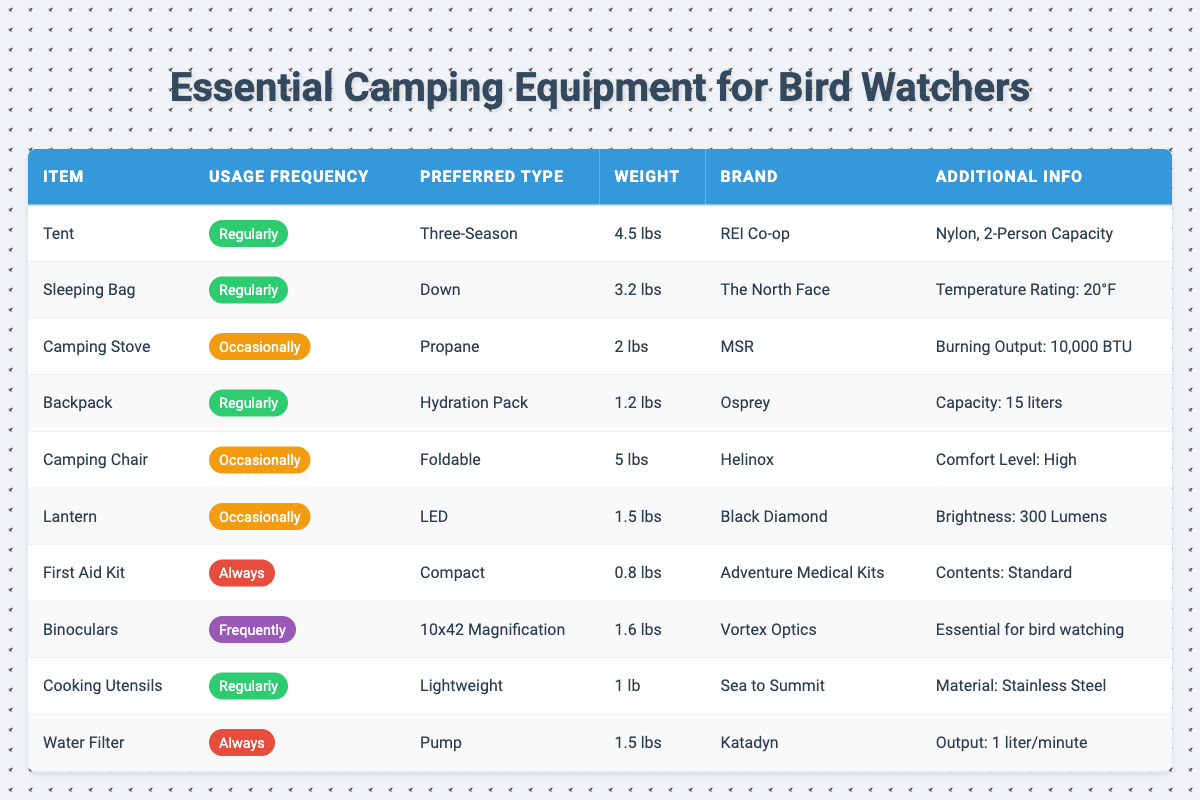What camping equipment is used regularly by travelers? We look for items listed with "Regularly" under the Usage Frequency column in the table. These items are: Tent, Sleeping Bag, Backpack, Cooking Utensils.
Answer: Tent, Sleeping Bag, Backpack, Cooking Utensils Which equipment has the highest weight? Check the Weight column for each item and identify the item with the largest value. Comparing weights, the Camping Chair is the heaviest at 5 lbs.
Answer: Camping Chair Is the First Aid Kit always used according to the table? The Usage Frequency for the First Aid Kit is labeled as "Always," which confirms that this item is consistently used.
Answer: Yes How many items are used occasionally? We need to count the items marked with "Occasionally" in the Usage Frequency column. There are three items: Camping Stove, Camping Chair, and Lantern.
Answer: 3 What is the total weight of the sleeping gear (Sleeping Bag and First Aid Kit)? First, we find the weights of Sleeping Bag (3.2 lbs) and First Aid Kit (0.8 lbs). Then we add them: 3.2 + 0.8 = 4.0 lbs.
Answer: 4.0 lbs Which brand offers a lightweight cooking utensil? We look in the table for the cooking utensil with the attribute "Lightweight," which identifies Sea to Summit as the brand for that category.
Answer: Sea to Summit What is the total weight of all the camping equipment used regularly? We calculate the sum of the weights of the items marked "Regularly": Tent (4.5 lbs), Sleeping Bag (3.2 lbs), Backpack (1.2 lbs), and Cooking Utensils (1 lb). Total weight = 4.5 + 3.2 + 1.2 + 1 = 10 lbs.
Answer: 10 lbs Is it true that all the listed items come from different brands? Review the Brand column for duplicate values. The table shows "The North Face" and "REI Co-op" appear as different brands without duplicates for any item.
Answer: Yes Which piece of camping equipment is most essential for bird watching? The table notes that the Binoculars are essential for bird watching, as directly mentioned.
Answer: Binoculars 